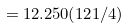<formula> <loc_0><loc_0><loc_500><loc_500>= 1 2 . 2 5 0 ( 1 2 1 / 4 )</formula> 